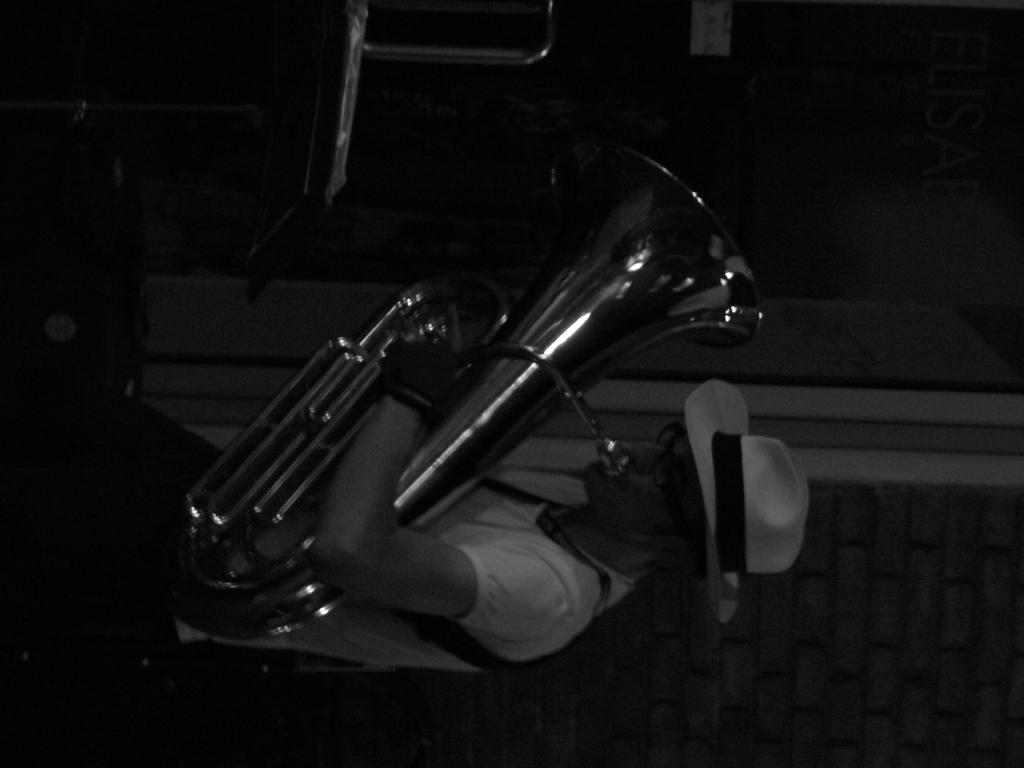What is the main subject of the image? The main subject of the image is a man. What is the man doing in the image? The man is playing a musical instrument in the image. Where is the shelf located in the image? There is no shelf present in the image. What rule is being enforced in the image? There is no rule being enforced in the image; it simply shows a man playing a musical instrument. 